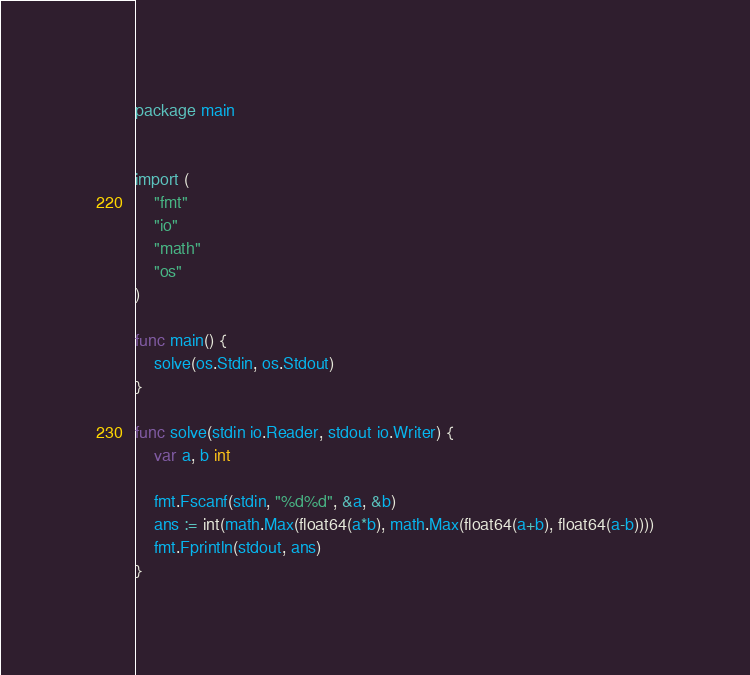<code> <loc_0><loc_0><loc_500><loc_500><_Go_>package main


import (
	"fmt"
	"io"
	"math"
	"os"
)

func main() {
	solve(os.Stdin, os.Stdout)
}

func solve(stdin io.Reader, stdout io.Writer) {
	var a, b int

	fmt.Fscanf(stdin, "%d%d", &a, &b)
	ans := int(math.Max(float64(a*b), math.Max(float64(a+b), float64(a-b))))
	fmt.Fprintln(stdout, ans)
}

</code> 